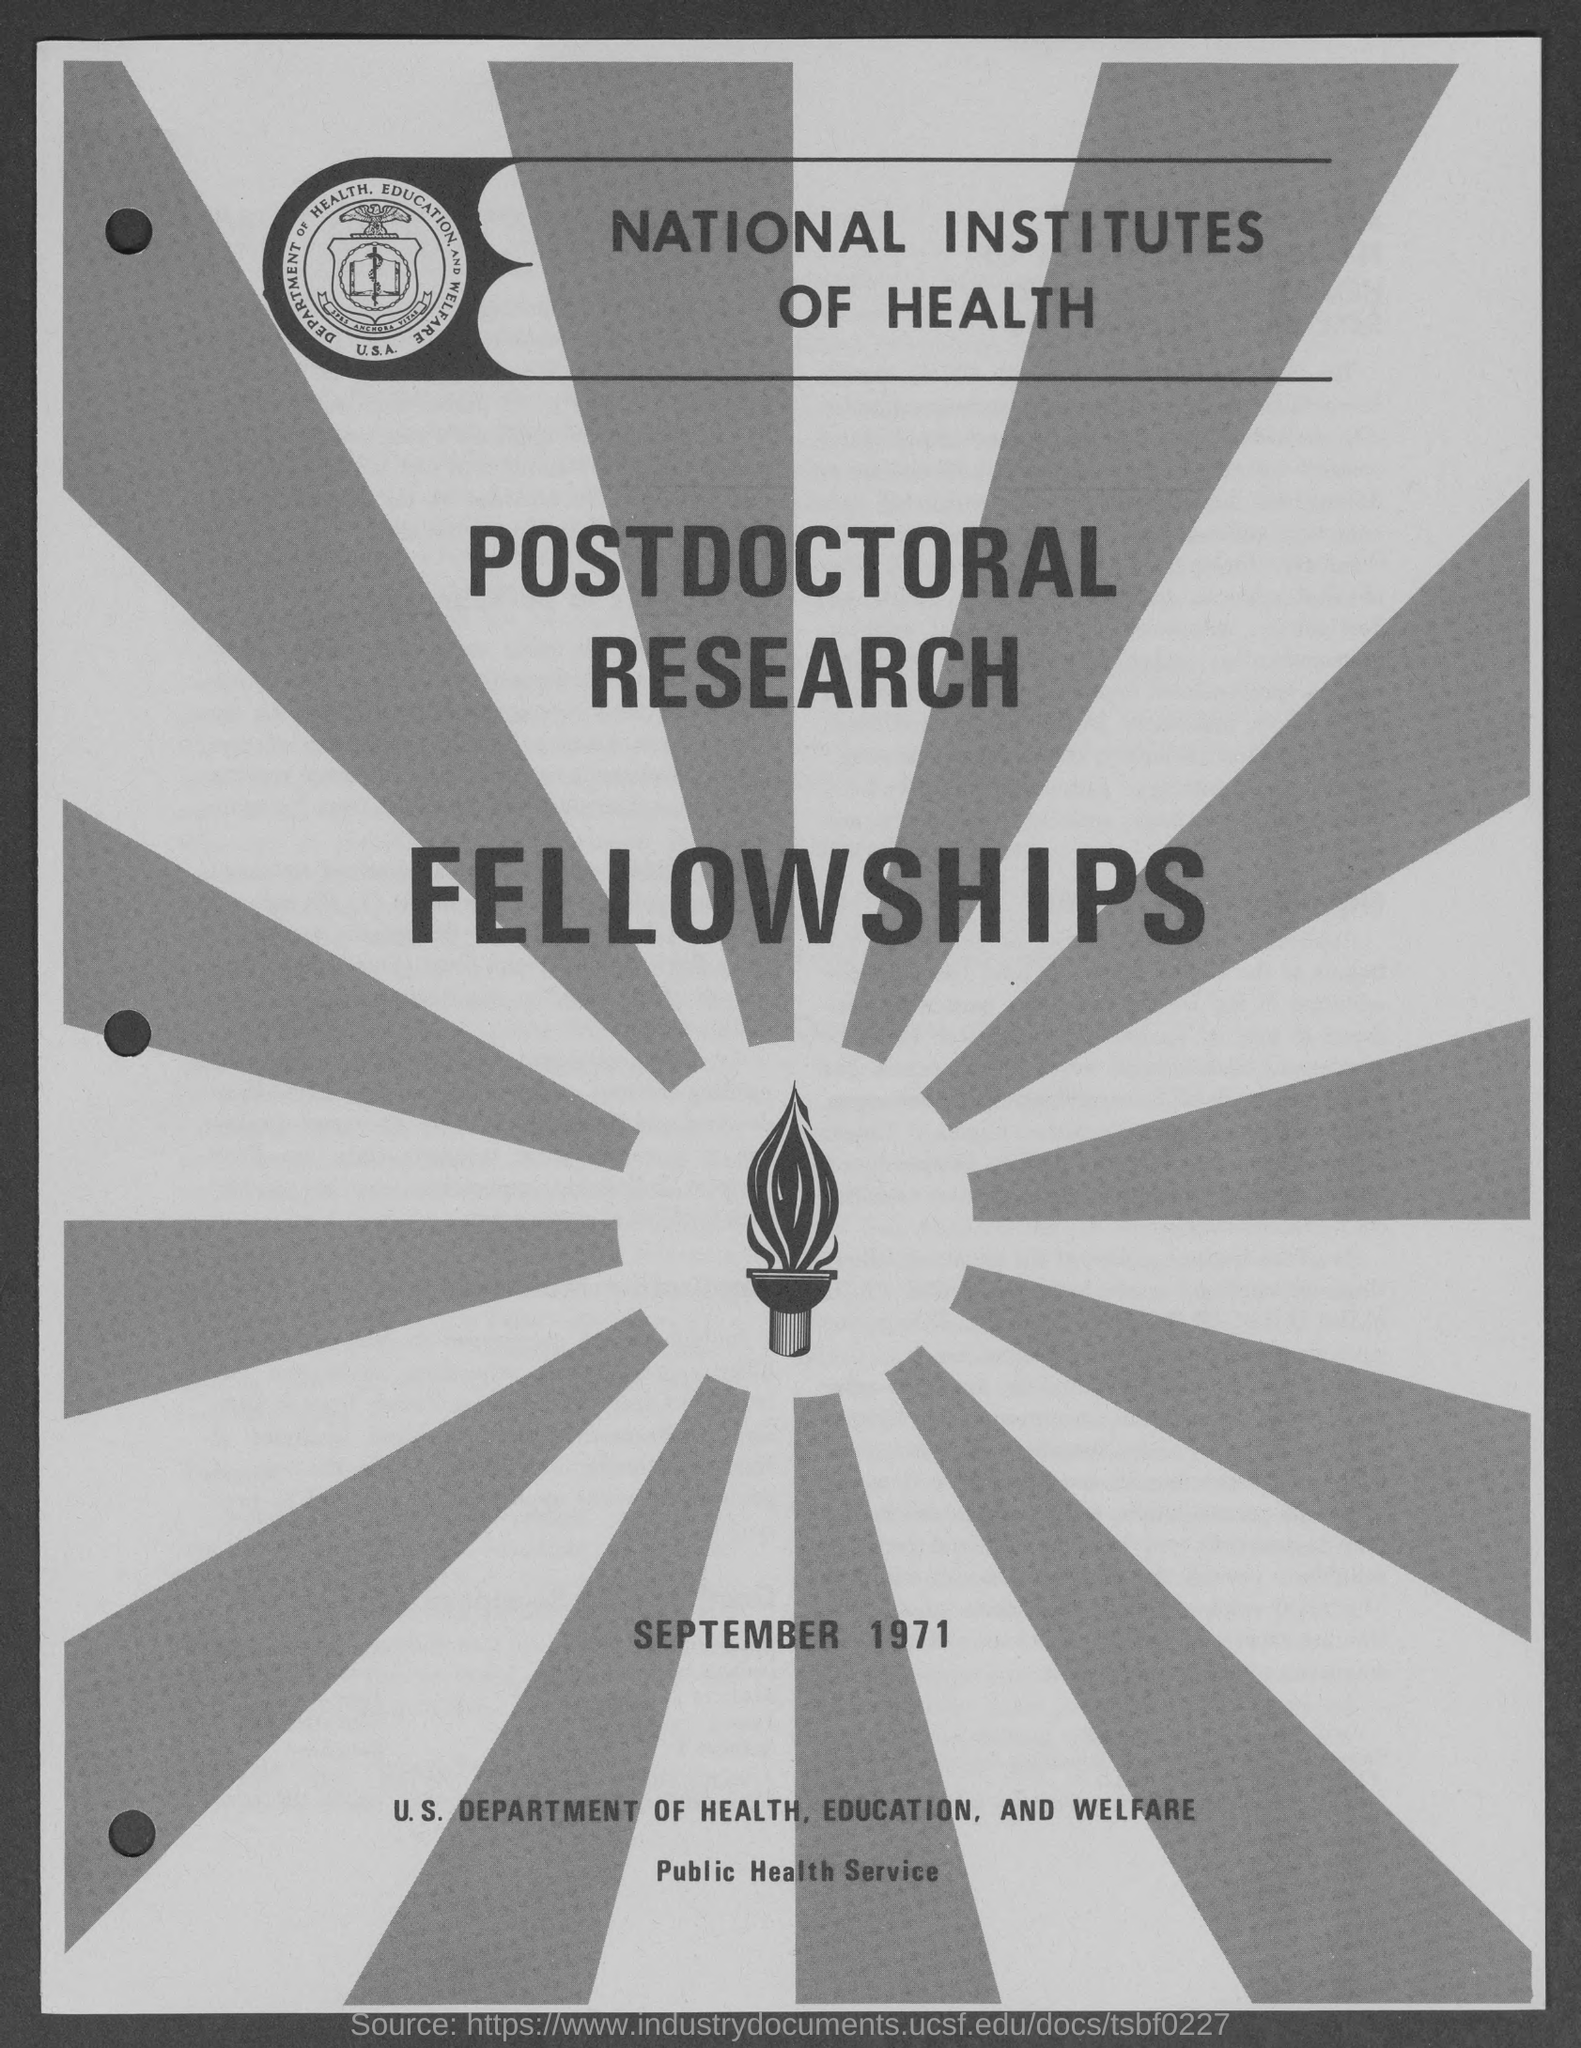Outline some significant characteristics in this image. The title of the document is 'NATIONAL INSTITUTES OF HEALTH.' The document is dated September 1971. 